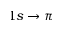<formula> <loc_0><loc_0><loc_500><loc_500>1 s \rightarrow \pi</formula> 